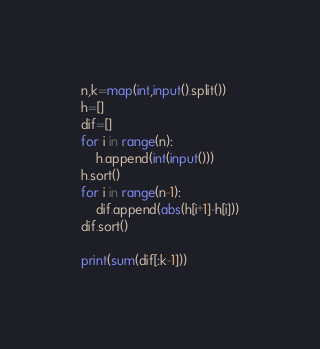<code> <loc_0><loc_0><loc_500><loc_500><_Python_>n,k=map(int,input().split())
h=[]
dif=[]
for i in range(n):
    h.append(int(input()))
h.sort()
for i in range(n-1):
    dif.append(abs(h[i+1]-h[i]))
dif.sort()

print(sum(dif[:k-1]))
</code> 